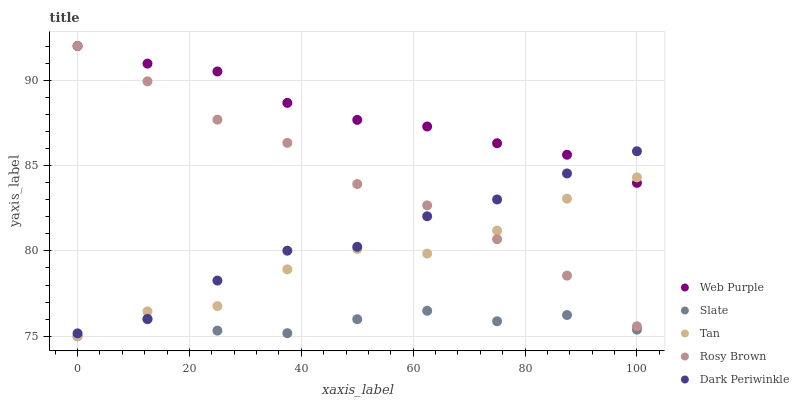Does Slate have the minimum area under the curve?
Answer yes or no. Yes. Does Web Purple have the maximum area under the curve?
Answer yes or no. Yes. Does Rosy Brown have the minimum area under the curve?
Answer yes or no. No. Does Rosy Brown have the maximum area under the curve?
Answer yes or no. No. Is Rosy Brown the smoothest?
Answer yes or no. Yes. Is Tan the roughest?
Answer yes or no. Yes. Is Tan the smoothest?
Answer yes or no. No. Is Rosy Brown the roughest?
Answer yes or no. No. Does Tan have the lowest value?
Answer yes or no. Yes. Does Rosy Brown have the lowest value?
Answer yes or no. No. Does Rosy Brown have the highest value?
Answer yes or no. Yes. Does Tan have the highest value?
Answer yes or no. No. Is Slate less than Rosy Brown?
Answer yes or no. Yes. Is Dark Periwinkle greater than Slate?
Answer yes or no. Yes. Does Tan intersect Rosy Brown?
Answer yes or no. Yes. Is Tan less than Rosy Brown?
Answer yes or no. No. Is Tan greater than Rosy Brown?
Answer yes or no. No. Does Slate intersect Rosy Brown?
Answer yes or no. No. 